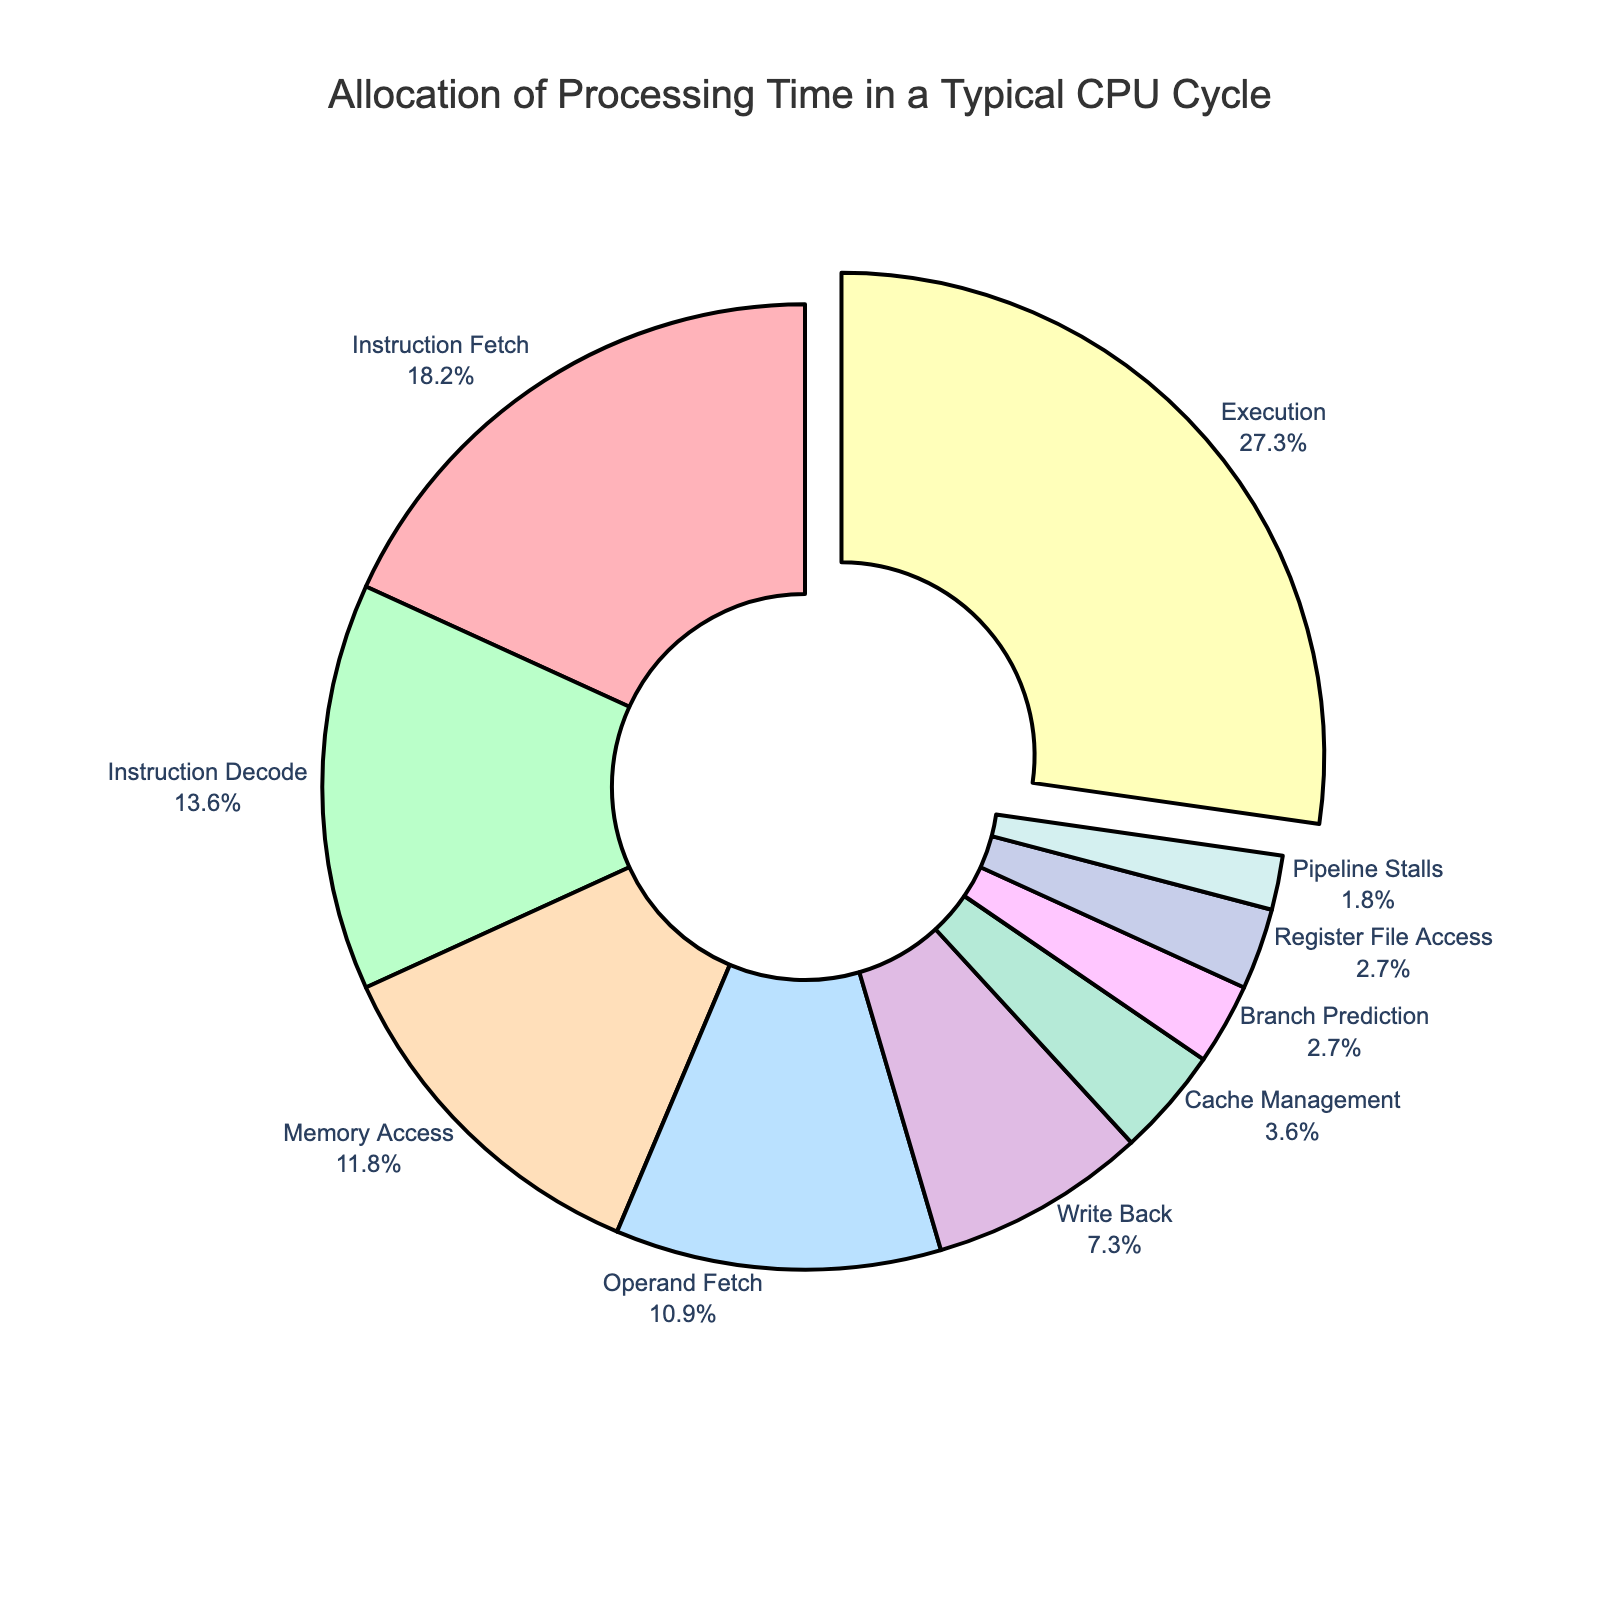What is the most time-consuming component in the CPU cycle? The figure highlights the "Execution" component by pulling it out slightly from the rest of the pie chart, indicating it's the largest. The percentage for "Execution" is also shown as 30%.
Answer: Execution Which component takes up less processing time: Instruction Fetch or Memory Access? By comparing the percentages shown, Instruction Fetch (20%) is greater than Memory Access (13%).
Answer: Memory Access What is the combined percentage of "Instruction Fetch" and "Instruction Decode"? Adding the percentages of Instruction Fetch (20%) and Instruction Decode (15%), we get 20% + 15% = 35%.
Answer: 35% Which component has the smallest allocation of processing time? By observing the chart, "Pipeline Stalls" is the smallest segment with 2%.
Answer: Pipeline Stalls How much more processing time does "Execution" take compared to "Write Back"? Subtracting the percentage of Write Back (8%) from Execution (30%), we get 30% - 8% = 22%.
Answer: 22% Which component's processing time is visually represented with a green color? By examining the color legend in the pie chart, "Instruction Decode" is visually represented with green.
Answer: Instruction Decode What is the percentage difference between "Operand Fetch" and "Cache Management"? The percentage for Operand Fetch is 12% and for Cache Management is 4%. The difference is 12% - 4% = 8%.
Answer: 8% Which two components combined have a processing time percentage equal to "Execution"? "Instruction Fetch" and "Instruction Decode" have combined percentages of 20% + 15% = 35%, which is equal to the "Execution" percentage of 30%.
Answer: Instruction Fetch and Instruction Decode 